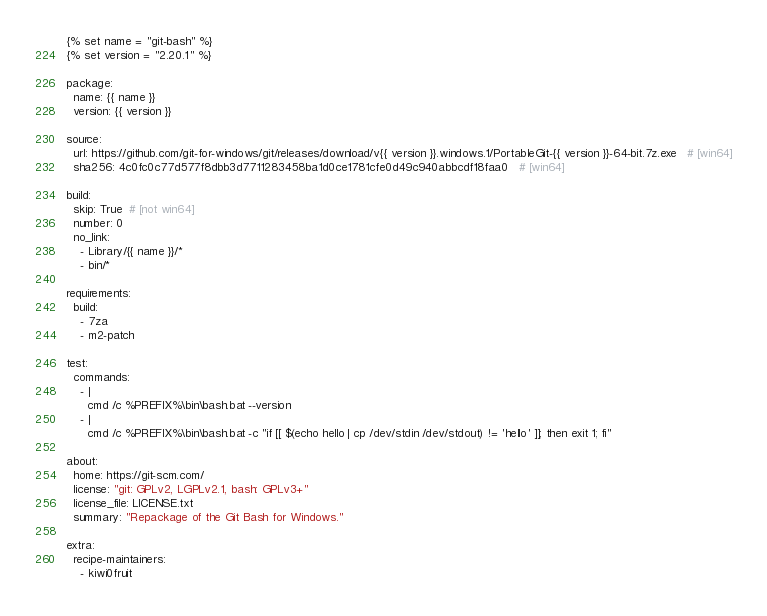<code> <loc_0><loc_0><loc_500><loc_500><_YAML_>{% set name = "git-bash" %}
{% set version = "2.20.1" %}

package:
  name: {{ name }}
  version: {{ version }}

source:
  url: https://github.com/git-for-windows/git/releases/download/v{{ version }}.windows.1/PortableGit-{{ version }}-64-bit.7z.exe   # [win64]
  sha256: 4c0fc0c77d577f8dbb3d7711283458ba1d0ce1781cfe0d49c940abbcdf18faa0   # [win64]

build:
  skip: True  # [not win64]
  number: 0
  no_link:
    - Library/{{ name }}/*
    - bin/*

requirements:
  build:
    - 7za
    - m2-patch

test:
  commands:
    - |
      cmd /c %PREFIX%\bin\bash.bat --version
    - |
      cmd /c %PREFIX%\bin\bash.bat -c "if [[ $(echo hello | cp /dev/stdin /dev/stdout) != 'hello' ]]; then exit 1; fi"

about:
  home: https://git-scm.com/
  license: "git: GPLv2, LGPLv2.1, bash: GPLv3+"
  license_file: LICENSE.txt
  summary: "Repackage of the Git Bash for Windows."

extra:
  recipe-maintainers:
    - kiwi0fruit
</code> 